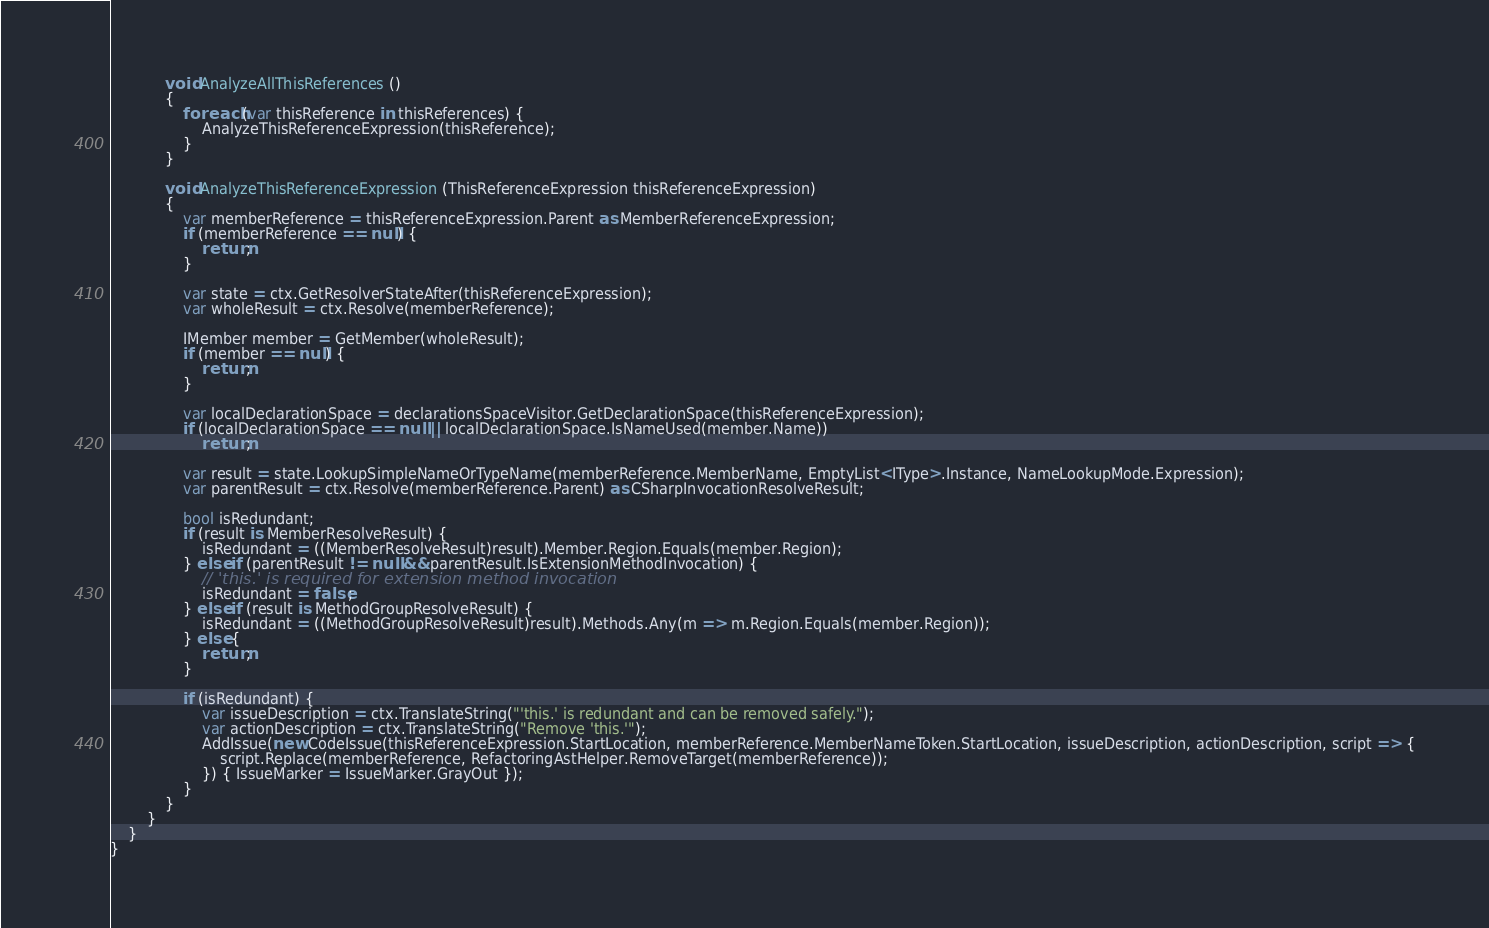Convert code to text. <code><loc_0><loc_0><loc_500><loc_500><_C#_>
			void AnalyzeAllThisReferences ()
			{
				foreach (var thisReference in thisReferences) {
					AnalyzeThisReferenceExpression(thisReference);
				}
			}

			void AnalyzeThisReferenceExpression (ThisReferenceExpression thisReferenceExpression)
			{
				var memberReference = thisReferenceExpression.Parent as MemberReferenceExpression;
				if (memberReference == null) {
					return;
				}

				var state = ctx.GetResolverStateAfter(thisReferenceExpression);
				var wholeResult = ctx.Resolve(memberReference);
			
				IMember member = GetMember(wholeResult);
				if (member == null) { 
					return;
				}

				var localDeclarationSpace = declarationsSpaceVisitor.GetDeclarationSpace(thisReferenceExpression);
				if (localDeclarationSpace == null || localDeclarationSpace.IsNameUsed(member.Name))
					return;

				var result = state.LookupSimpleNameOrTypeName(memberReference.MemberName, EmptyList<IType>.Instance, NameLookupMode.Expression);
				var parentResult = ctx.Resolve(memberReference.Parent) as CSharpInvocationResolveResult;
				
				bool isRedundant;
				if (result is MemberResolveResult) {
					isRedundant = ((MemberResolveResult)result).Member.Region.Equals(member.Region);
				} else if (parentResult != null && parentResult.IsExtensionMethodInvocation) {
					// 'this.' is required for extension method invocation
					isRedundant = false;
				} else if (result is MethodGroupResolveResult) {
					isRedundant = ((MethodGroupResolveResult)result).Methods.Any(m => m.Region.Equals(member.Region));
				} else {
					return;
				}

				if (isRedundant) {
					var issueDescription = ctx.TranslateString("'this.' is redundant and can be removed safely.");
					var actionDescription = ctx.TranslateString("Remove 'this.'");
					AddIssue(new CodeIssue(thisReferenceExpression.StartLocation, memberReference.MemberNameToken.StartLocation, issueDescription, actionDescription, script => {
						script.Replace(memberReference, RefactoringAstHelper.RemoveTarget(memberReference));
					}) { IssueMarker = IssueMarker.GrayOut });
				}
			}
		}
	}
}</code> 